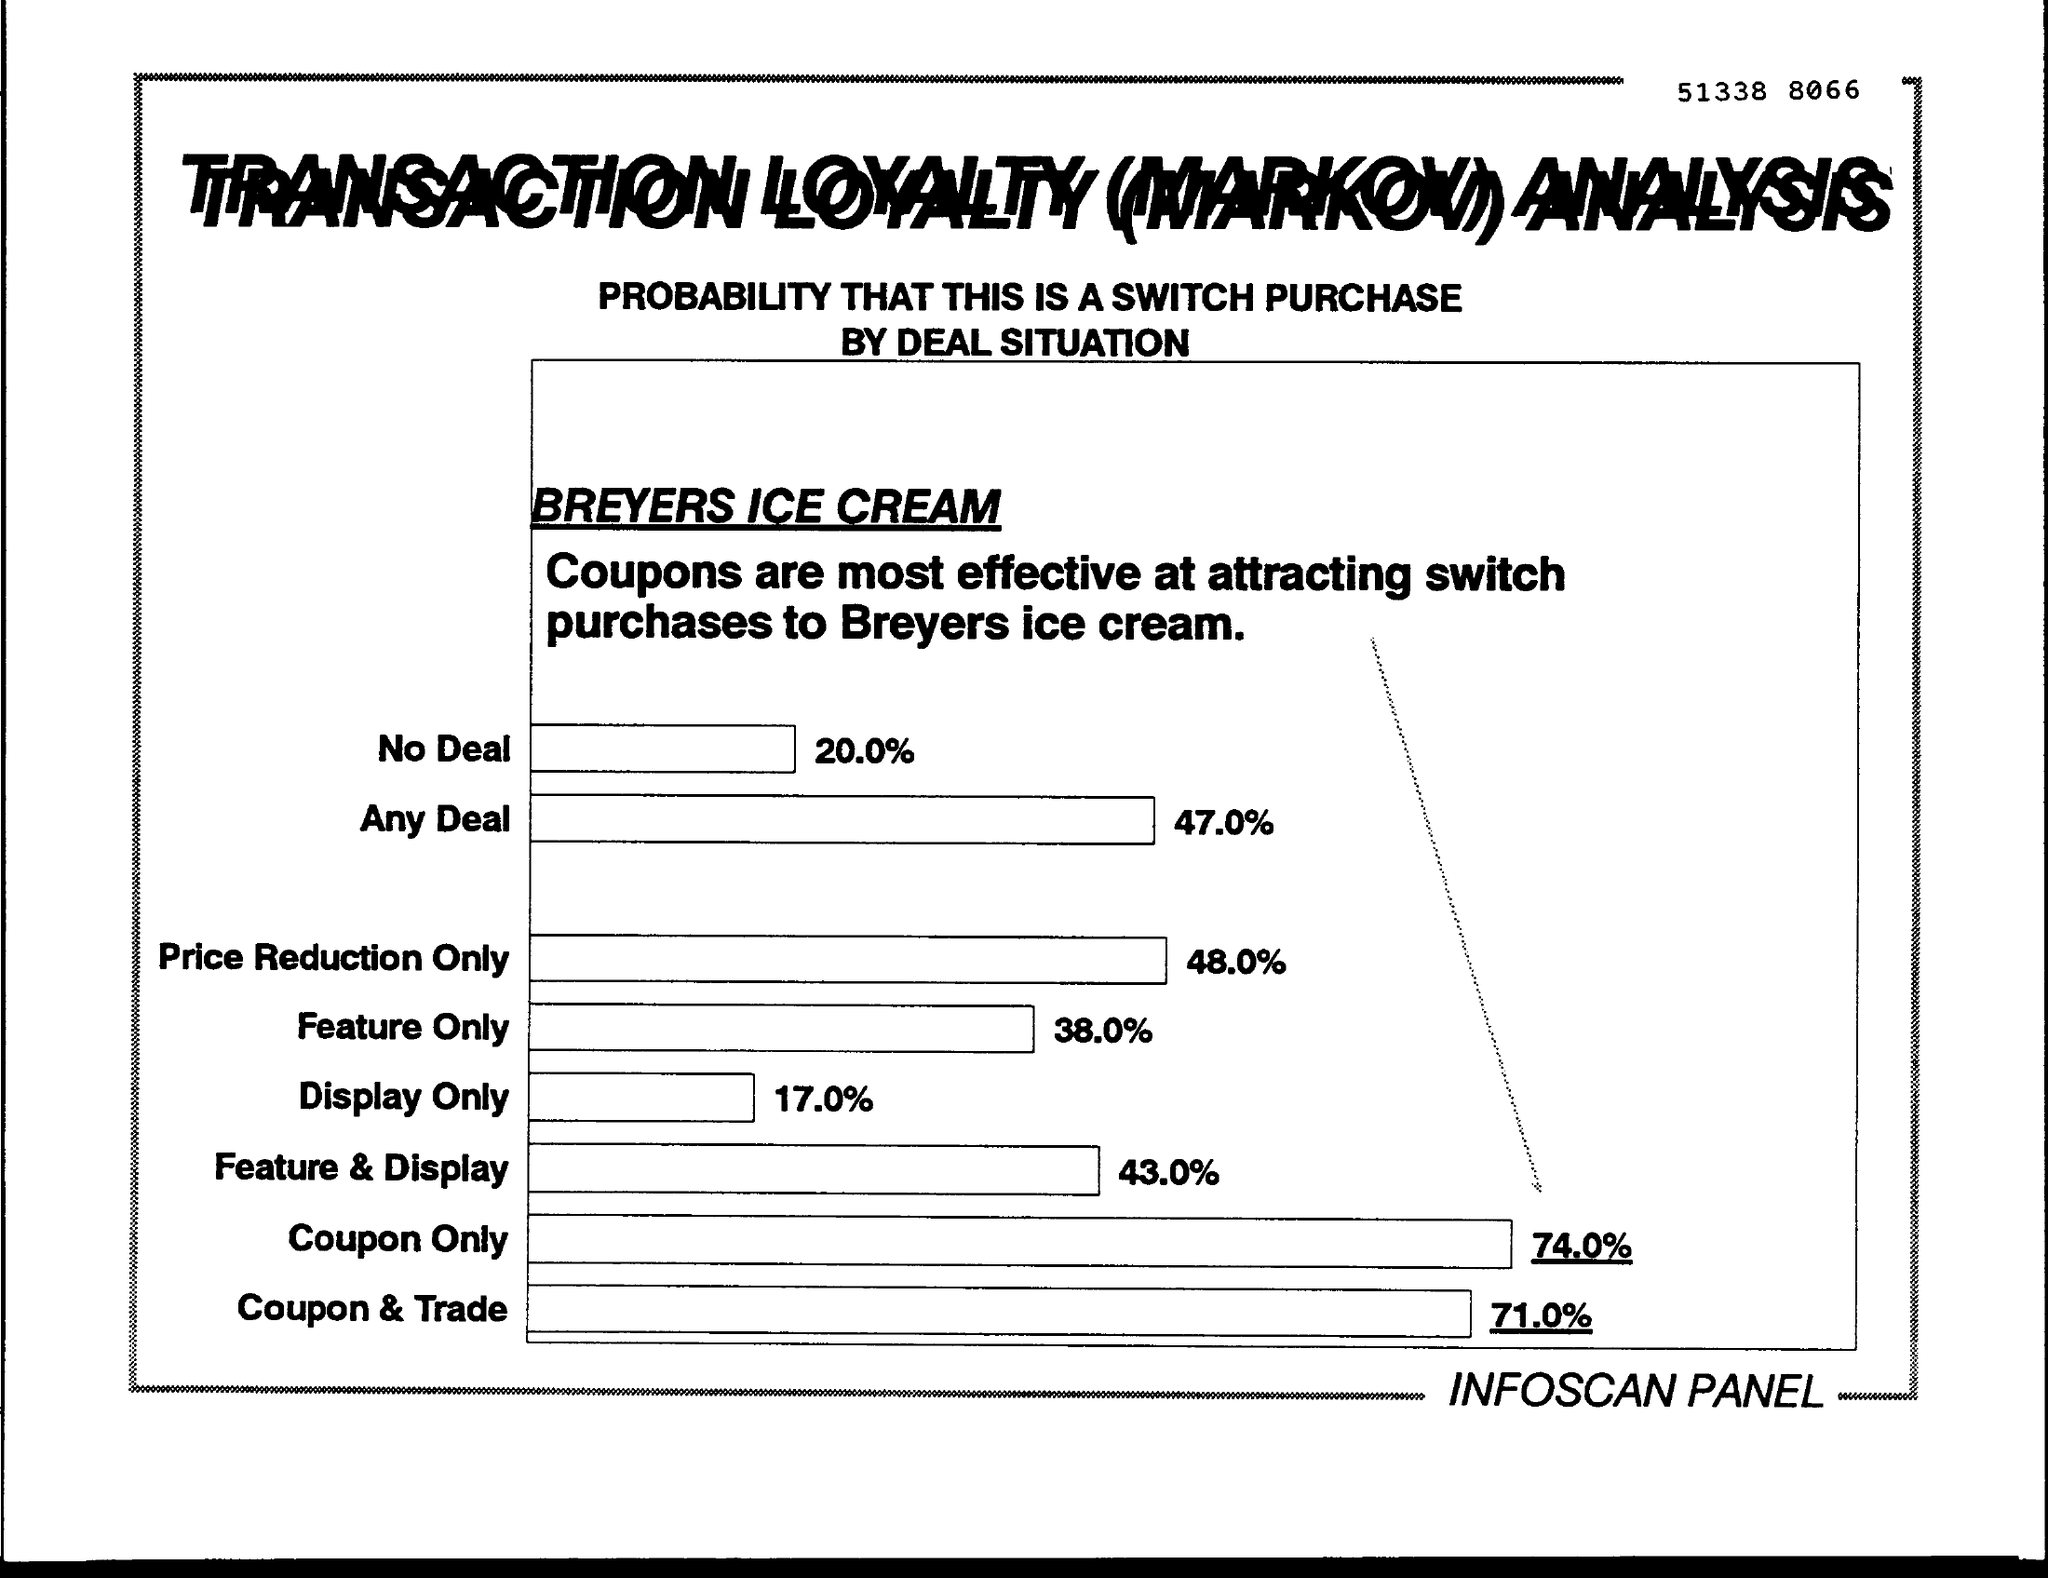Highlight a few significant elements in this photo. A recent survey conducted on the effectiveness of coupons in attracting switch purchases for Breyer's ice cream revealed that a significant 71.0% of respondents reported that coupons are an effective method for attracting switch purchases. Breyer's ice cream attracts 17.0% of its potential customers through its display. Breyer's ice cream offers a price reduction of 48.0% on purchases made through the switch app. The percentage of no deal in a switch purchase of BREYERS ice cream is 20.0%. 